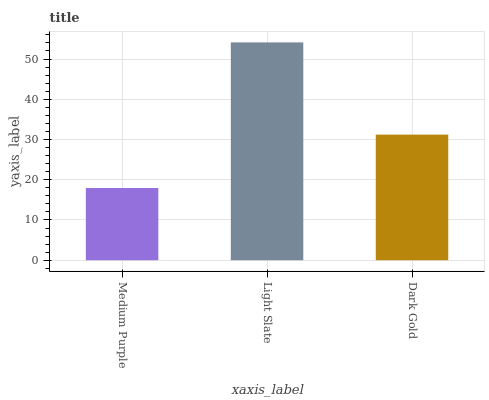Is Medium Purple the minimum?
Answer yes or no. Yes. Is Light Slate the maximum?
Answer yes or no. Yes. Is Dark Gold the minimum?
Answer yes or no. No. Is Dark Gold the maximum?
Answer yes or no. No. Is Light Slate greater than Dark Gold?
Answer yes or no. Yes. Is Dark Gold less than Light Slate?
Answer yes or no. Yes. Is Dark Gold greater than Light Slate?
Answer yes or no. No. Is Light Slate less than Dark Gold?
Answer yes or no. No. Is Dark Gold the high median?
Answer yes or no. Yes. Is Dark Gold the low median?
Answer yes or no. Yes. Is Light Slate the high median?
Answer yes or no. No. Is Medium Purple the low median?
Answer yes or no. No. 